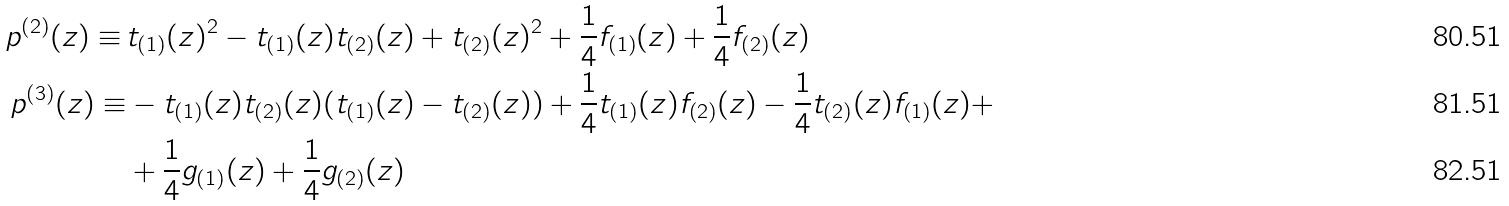Convert formula to latex. <formula><loc_0><loc_0><loc_500><loc_500>p ^ { ( 2 ) } ( z ) \equiv \, & t _ { ( 1 ) } ( z ) ^ { 2 } - t _ { ( 1 ) } ( z ) t _ { ( 2 ) } ( z ) + t _ { ( 2 ) } ( z ) ^ { 2 } + \frac { 1 } { 4 } f _ { ( 1 ) } ( z ) + \frac { 1 } { 4 } f _ { ( 2 ) } ( z ) \\ p ^ { ( 3 ) } ( z ) \equiv & - t _ { ( 1 ) } ( z ) t _ { ( 2 ) } ( z ) ( t _ { ( 1 ) } ( z ) - t _ { ( 2 ) } ( z ) ) + \frac { 1 } { 4 } t _ { ( 1 ) } ( z ) f _ { ( 2 ) } ( z ) - \frac { 1 } { 4 } t _ { ( 2 ) } ( z ) f _ { ( 1 ) } ( z ) + \\ & + \frac { 1 } { 4 } g _ { ( 1 ) } ( z ) + \frac { 1 } { 4 } g _ { ( 2 ) } ( z )</formula> 